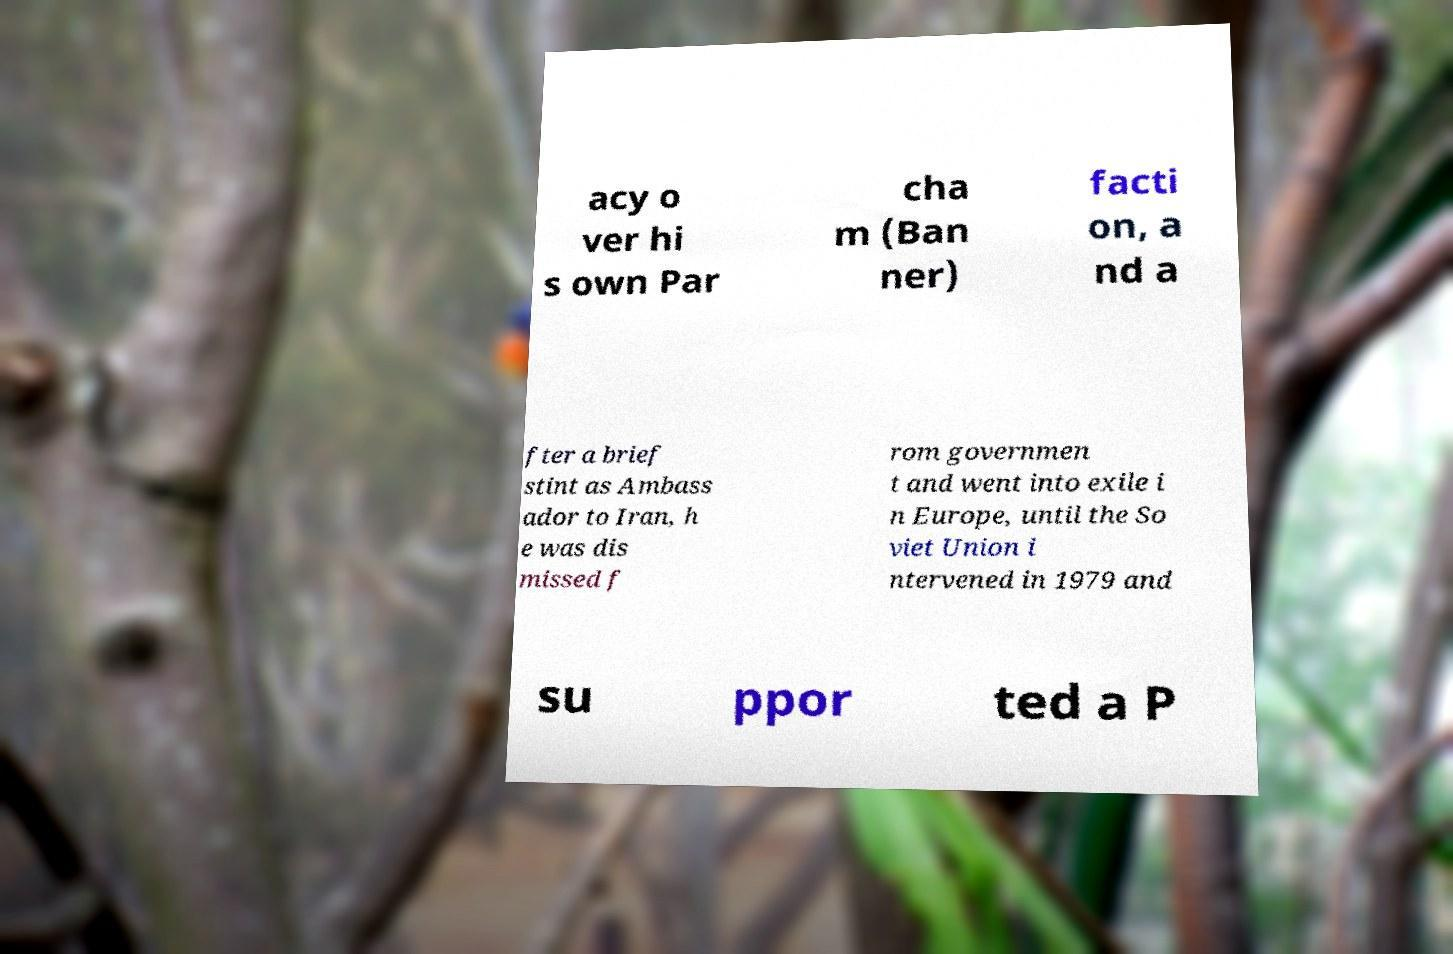For documentation purposes, I need the text within this image transcribed. Could you provide that? acy o ver hi s own Par cha m (Ban ner) facti on, a nd a fter a brief stint as Ambass ador to Iran, h e was dis missed f rom governmen t and went into exile i n Europe, until the So viet Union i ntervened in 1979 and su ppor ted a P 